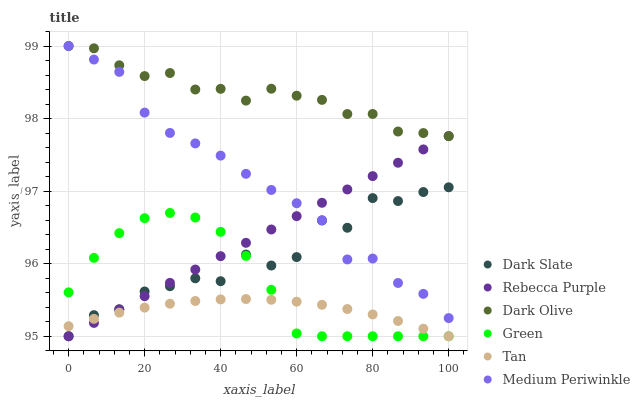Does Tan have the minimum area under the curve?
Answer yes or no. Yes. Does Dark Olive have the maximum area under the curve?
Answer yes or no. Yes. Does Medium Periwinkle have the minimum area under the curve?
Answer yes or no. No. Does Medium Periwinkle have the maximum area under the curve?
Answer yes or no. No. Is Rebecca Purple the smoothest?
Answer yes or no. Yes. Is Dark Slate the roughest?
Answer yes or no. Yes. Is Medium Periwinkle the smoothest?
Answer yes or no. No. Is Medium Periwinkle the roughest?
Answer yes or no. No. Does Dark Slate have the lowest value?
Answer yes or no. Yes. Does Medium Periwinkle have the lowest value?
Answer yes or no. No. Does Medium Periwinkle have the highest value?
Answer yes or no. Yes. Does Dark Slate have the highest value?
Answer yes or no. No. Is Green less than Medium Periwinkle?
Answer yes or no. Yes. Is Dark Olive greater than Dark Slate?
Answer yes or no. Yes. Does Dark Slate intersect Medium Periwinkle?
Answer yes or no. Yes. Is Dark Slate less than Medium Periwinkle?
Answer yes or no. No. Is Dark Slate greater than Medium Periwinkle?
Answer yes or no. No. Does Green intersect Medium Periwinkle?
Answer yes or no. No. 